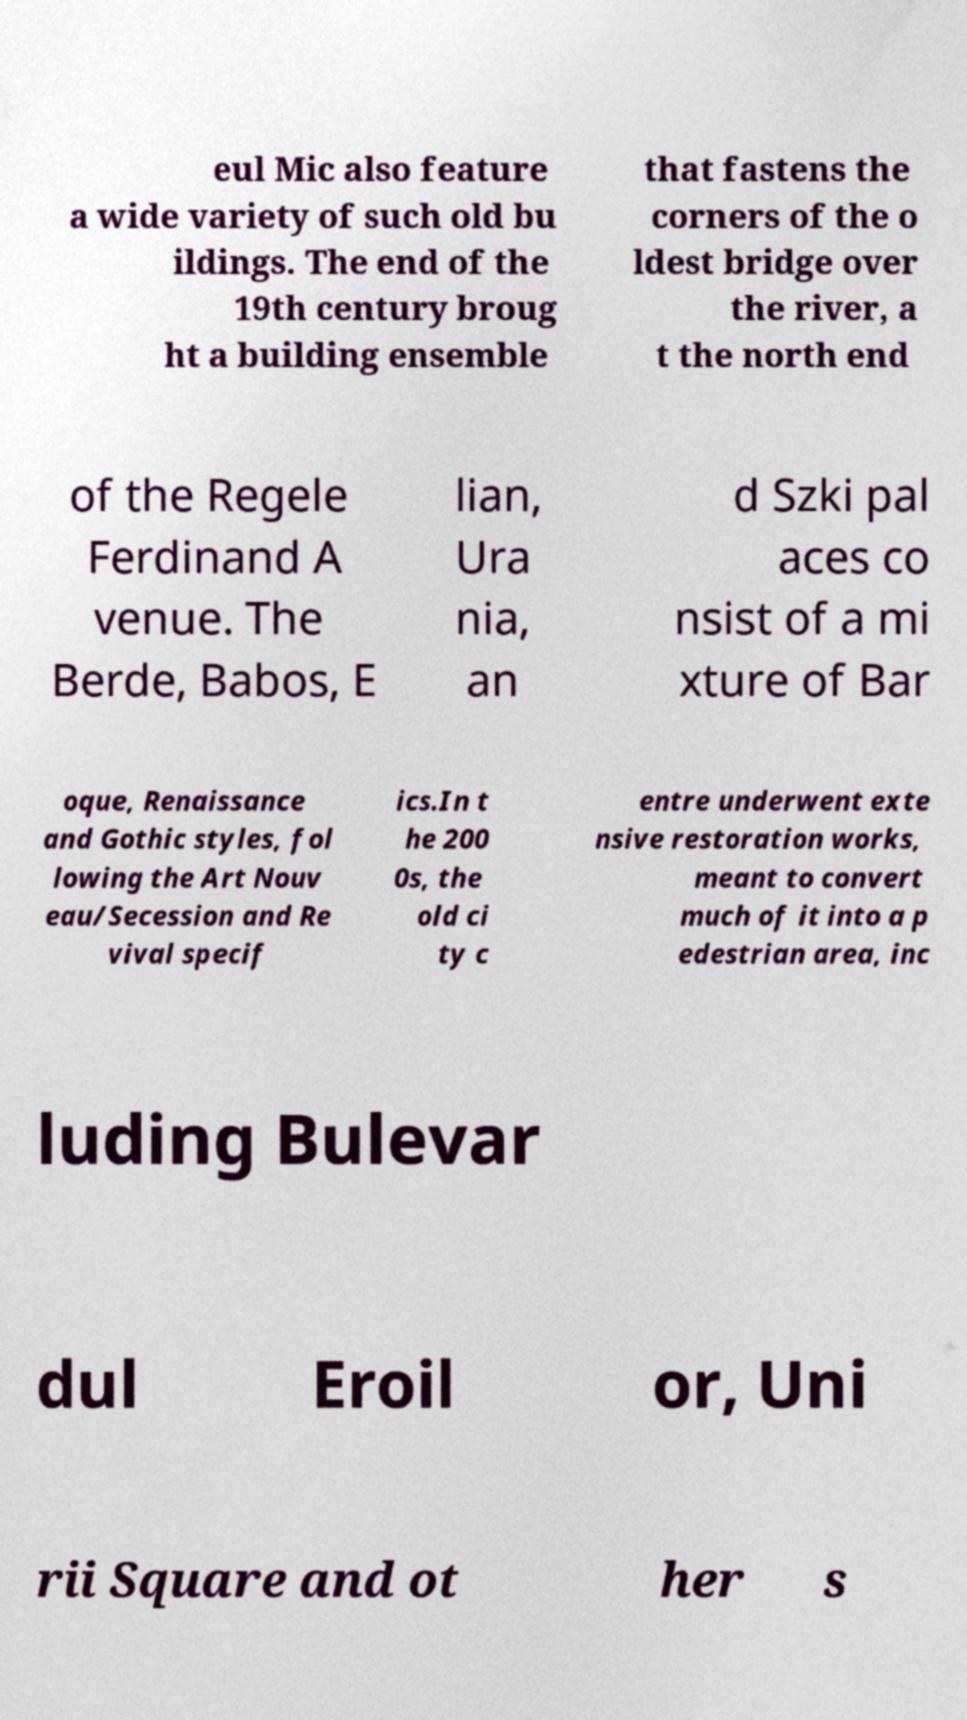There's text embedded in this image that I need extracted. Can you transcribe it verbatim? eul Mic also feature a wide variety of such old bu ildings. The end of the 19th century broug ht a building ensemble that fastens the corners of the o ldest bridge over the river, a t the north end of the Regele Ferdinand A venue. The Berde, Babos, E lian, Ura nia, an d Szki pal aces co nsist of a mi xture of Bar oque, Renaissance and Gothic styles, fol lowing the Art Nouv eau/Secession and Re vival specif ics.In t he 200 0s, the old ci ty c entre underwent exte nsive restoration works, meant to convert much of it into a p edestrian area, inc luding Bulevar dul Eroil or, Uni rii Square and ot her s 